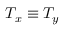<formula> <loc_0><loc_0><loc_500><loc_500>T _ { x } \equiv T _ { y }</formula> 